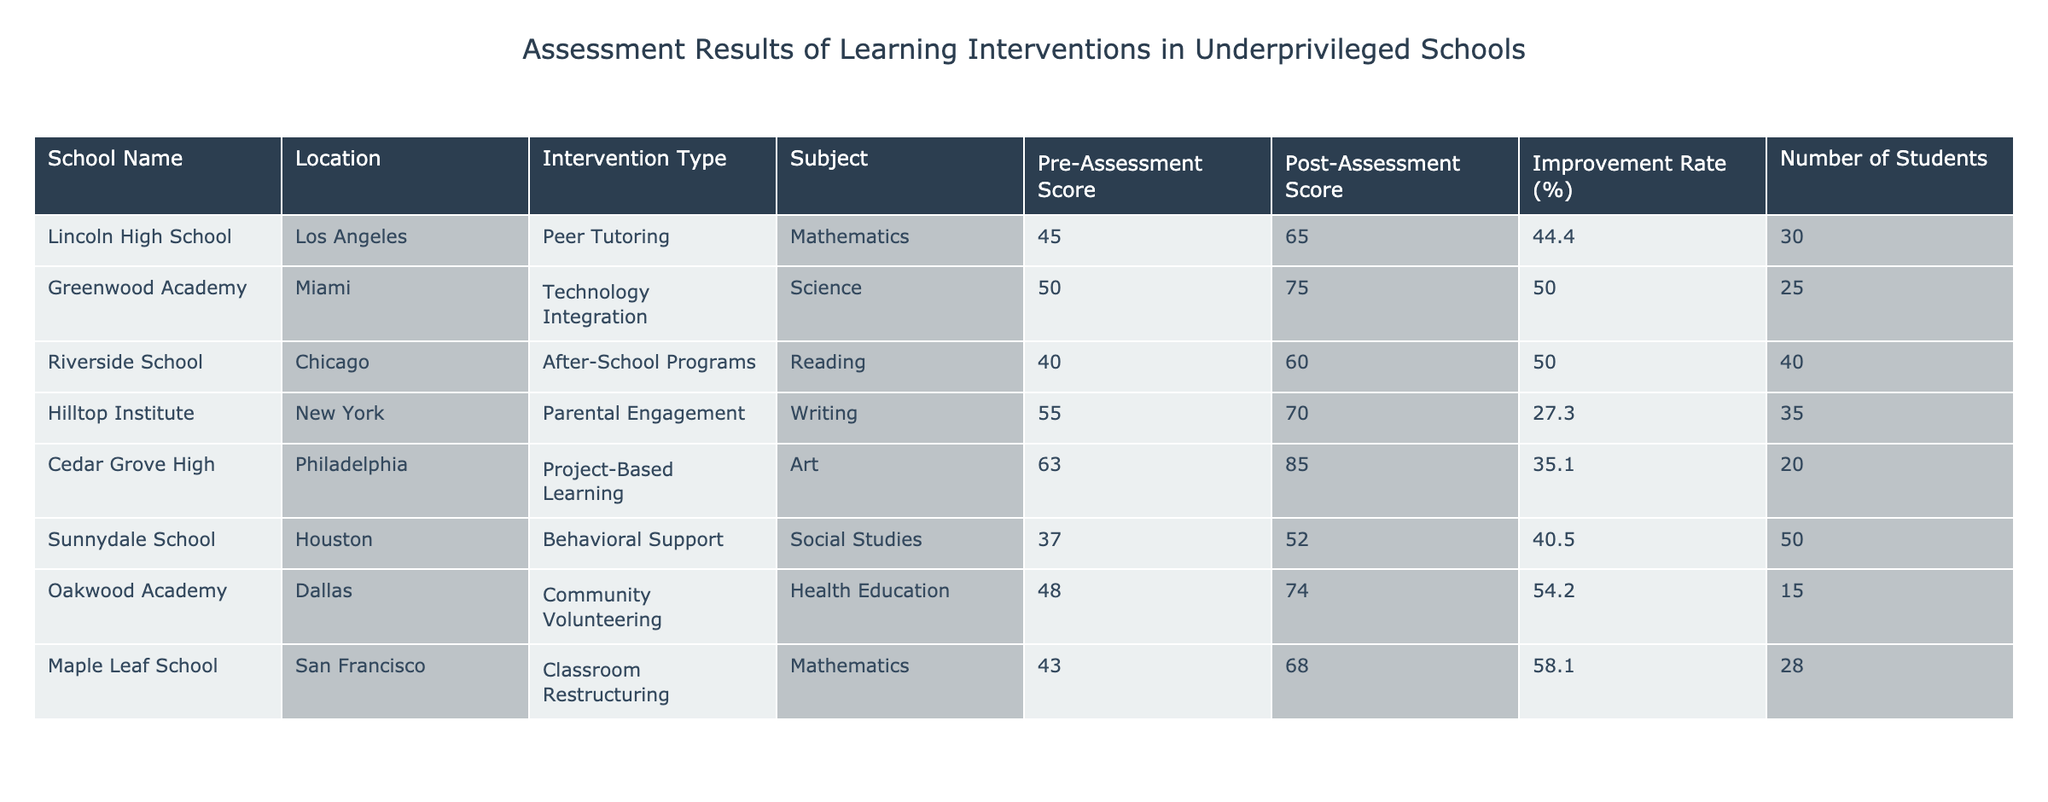What is the highest post-assessment score achieved by any school? From the table, the highest post-assessment score is found in Cedar Grove High, with a score of 85.
Answer: 85 Which school had the largest improvement rate and what was that rate? By comparing the improvement rates from the table, Oakwood Academy has the largest improvement rate at 54.2%.
Answer: 54.2% How many students participated in the intervention at Riverside School? The table indicates that 40 students participated in the intervention at Riverside School.
Answer: 40 Is the average pre-assessment score across all schools greater than 50? To find the average pre-assessment score, add all pre-assessment scores (45 + 50 + 40 + 55 + 63 + 37 + 48 + 43) = 381, and divide by the number of schools (8). 381/8 = 47.625, which is less than 50.
Answer: No What total number of students participated in the peer tutoring intervention? By looking at Lincoln High School's entry, 30 students participated in the peer tutoring intervention. No other school had this intervention listed in the table.
Answer: 30 What is the difference between the highest and lowest improvement rates? The highest improvement rate is 54.2% (Oakwood Academy) and the lowest is 27.3% (Hilltop Institute). The difference is 54.2 - 27.3 = 26.9%.
Answer: 26.9% Did any schools receive a post-assessment score below 60? Upon reviewing the table, Sunnydale School has a post-assessment score of 52, thus indicating that yes, at least one school received a post-assessment score below 60.
Answer: Yes Which subject had the lowest pre-assessment score in the data set? The lowest pre-assessment score documented in the table is from Sunnydale School for Social Studies with a score of 37.
Answer: 37 